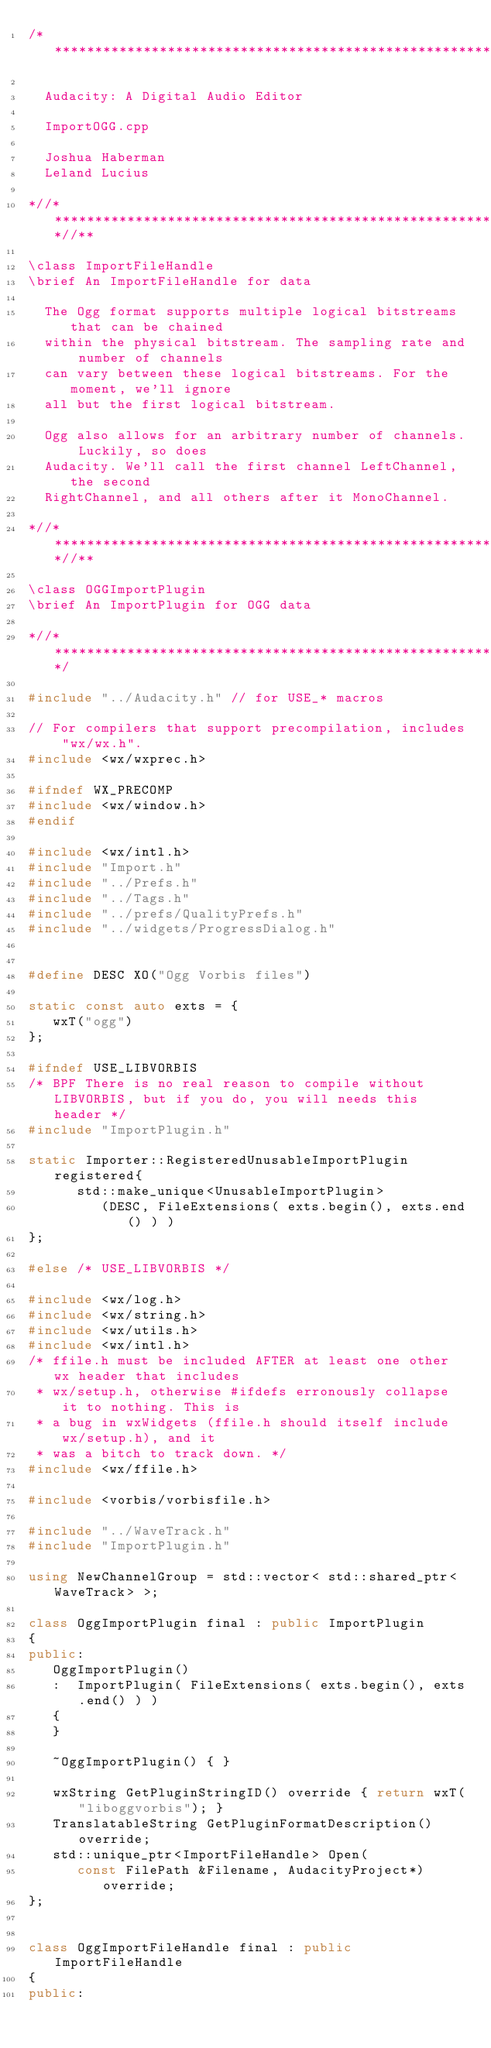<code> <loc_0><loc_0><loc_500><loc_500><_C++_>/**********************************************************************

  Audacity: A Digital Audio Editor

  ImportOGG.cpp

  Joshua Haberman
  Leland Lucius

*//****************************************************************//**

\class ImportFileHandle
\brief An ImportFileHandle for data

  The Ogg format supports multiple logical bitstreams that can be chained
  within the physical bitstream. The sampling rate and number of channels
  can vary between these logical bitstreams. For the moment, we'll ignore
  all but the first logical bitstream.

  Ogg also allows for an arbitrary number of channels. Luckily, so does
  Audacity. We'll call the first channel LeftChannel, the second
  RightChannel, and all others after it MonoChannel.

*//****************************************************************//**

\class OGGImportPlugin
\brief An ImportPlugin for OGG data

*//*******************************************************************/

#include "../Audacity.h" // for USE_* macros

// For compilers that support precompilation, includes "wx/wx.h".
#include <wx/wxprec.h>

#ifndef WX_PRECOMP
#include <wx/window.h>
#endif

#include <wx/intl.h>
#include "Import.h"
#include "../Prefs.h"
#include "../Tags.h"
#include "../prefs/QualityPrefs.h"
#include "../widgets/ProgressDialog.h"


#define DESC XO("Ogg Vorbis files")

static const auto exts = {
   wxT("ogg")
};

#ifndef USE_LIBVORBIS
/* BPF There is no real reason to compile without LIBVORBIS, but if you do, you will needs this header */
#include "ImportPlugin.h"

static Importer::RegisteredUnusableImportPlugin registered{
      std::make_unique<UnusableImportPlugin>
         (DESC, FileExtensions( exts.begin(), exts.end() ) )
};

#else /* USE_LIBVORBIS */

#include <wx/log.h>
#include <wx/string.h>
#include <wx/utils.h>
#include <wx/intl.h>
/* ffile.h must be included AFTER at least one other wx header that includes
 * wx/setup.h, otherwise #ifdefs erronously collapse it to nothing. This is
 * a bug in wxWidgets (ffile.h should itself include wx/setup.h), and it
 * was a bitch to track down. */
#include <wx/ffile.h>

#include <vorbis/vorbisfile.h>

#include "../WaveTrack.h"
#include "ImportPlugin.h"

using NewChannelGroup = std::vector< std::shared_ptr<WaveTrack> >;

class OggImportPlugin final : public ImportPlugin
{
public:
   OggImportPlugin()
   :  ImportPlugin( FileExtensions( exts.begin(), exts.end() ) )
   {
   }

   ~OggImportPlugin() { }

   wxString GetPluginStringID() override { return wxT("liboggvorbis"); }
   TranslatableString GetPluginFormatDescription() override;
   std::unique_ptr<ImportFileHandle> Open(
      const FilePath &Filename, AudacityProject*) override;
};


class OggImportFileHandle final : public ImportFileHandle
{
public:</code> 